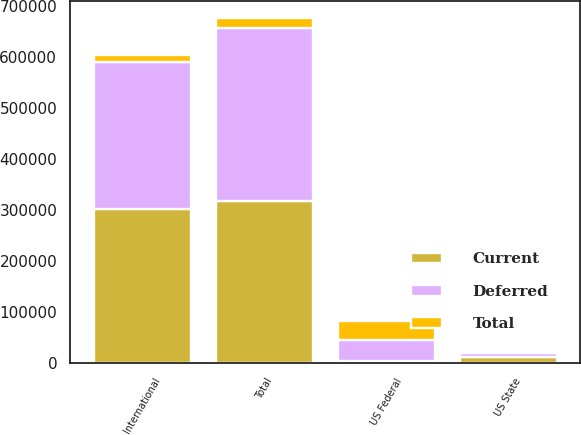Convert chart to OTSL. <chart><loc_0><loc_0><loc_500><loc_500><stacked_bar_chart><ecel><fcel>International<fcel>US Federal<fcel>US State<fcel>Total<nl><fcel>Current<fcel>302352<fcel>3681<fcel>12203<fcel>318236<nl><fcel>Total<fcel>13792<fcel>37956<fcel>4568<fcel>19596<nl><fcel>Deferred<fcel>288560<fcel>41637<fcel>7635<fcel>337832<nl></chart> 